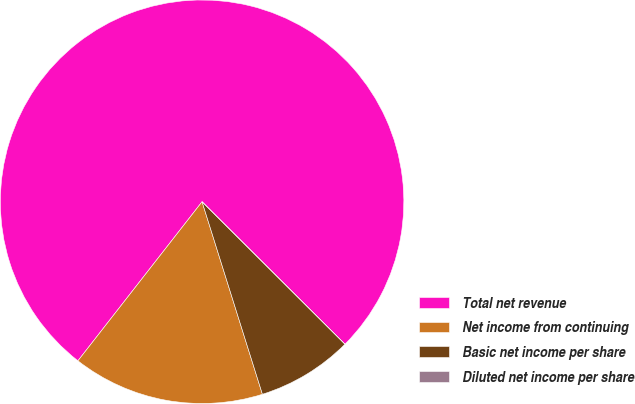<chart> <loc_0><loc_0><loc_500><loc_500><pie_chart><fcel>Total net revenue<fcel>Net income from continuing<fcel>Basic net income per share<fcel>Diluted net income per share<nl><fcel>76.92%<fcel>15.38%<fcel>7.69%<fcel>0.0%<nl></chart> 